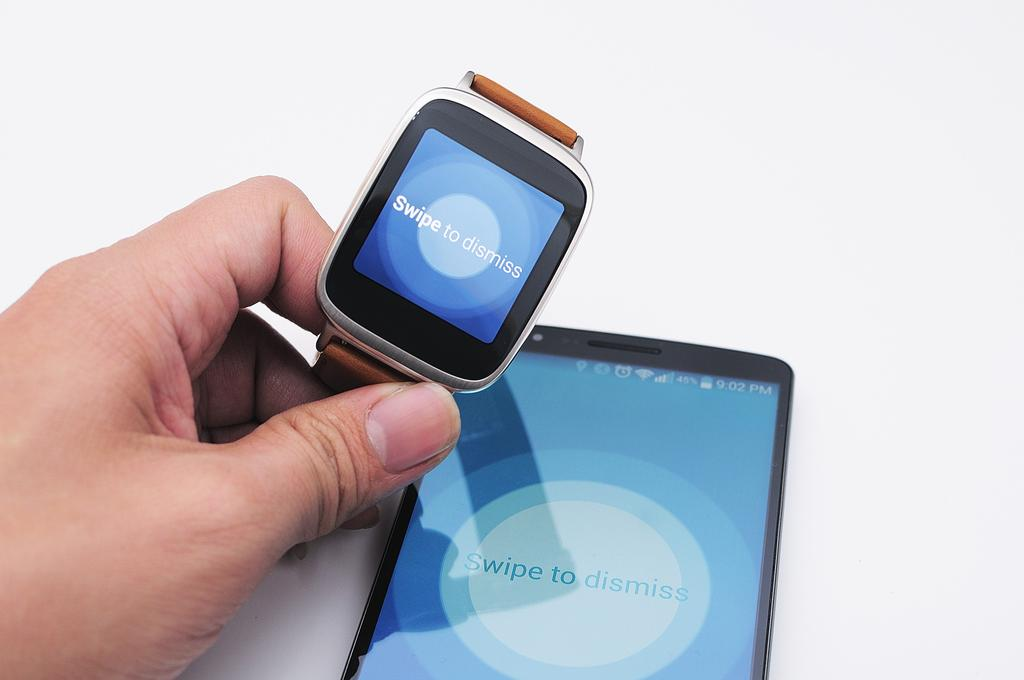<image>
Summarize the visual content of the image. A smartwatch and a phone both displaying Swipe to dismiss. 